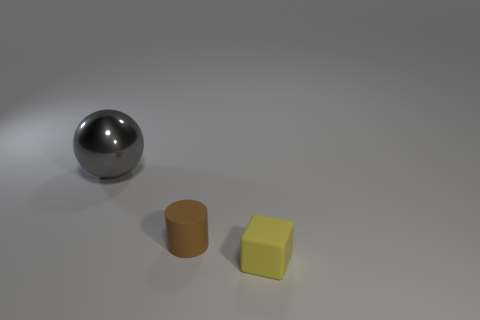What number of cylinders are either small red matte things or metal things?
Your answer should be very brief. 0. How many yellow objects have the same material as the tiny cylinder?
Offer a very short reply. 1. Does the tiny thing to the left of the small block have the same material as the large sphere behind the tiny yellow matte cube?
Your answer should be compact. No. There is a big gray thing that is behind the small thing that is in front of the tiny brown rubber cylinder; how many tiny cubes are to the right of it?
Keep it short and to the point. 1. There is a matte thing on the left side of the rubber thing that is on the right side of the matte cylinder; what color is it?
Keep it short and to the point. Brown. Are any small purple metallic cubes visible?
Give a very brief answer. No. There is a thing that is behind the yellow block and in front of the large sphere; what color is it?
Your answer should be compact. Brown. Do the matte thing that is to the left of the yellow cube and the gray sphere to the left of the small yellow matte thing have the same size?
Your answer should be compact. No. What number of other things are there of the same size as the gray thing?
Ensure brevity in your answer.  0. There is a tiny rubber thing on the left side of the tiny yellow block; what number of large balls are on the left side of it?
Make the answer very short. 1. 